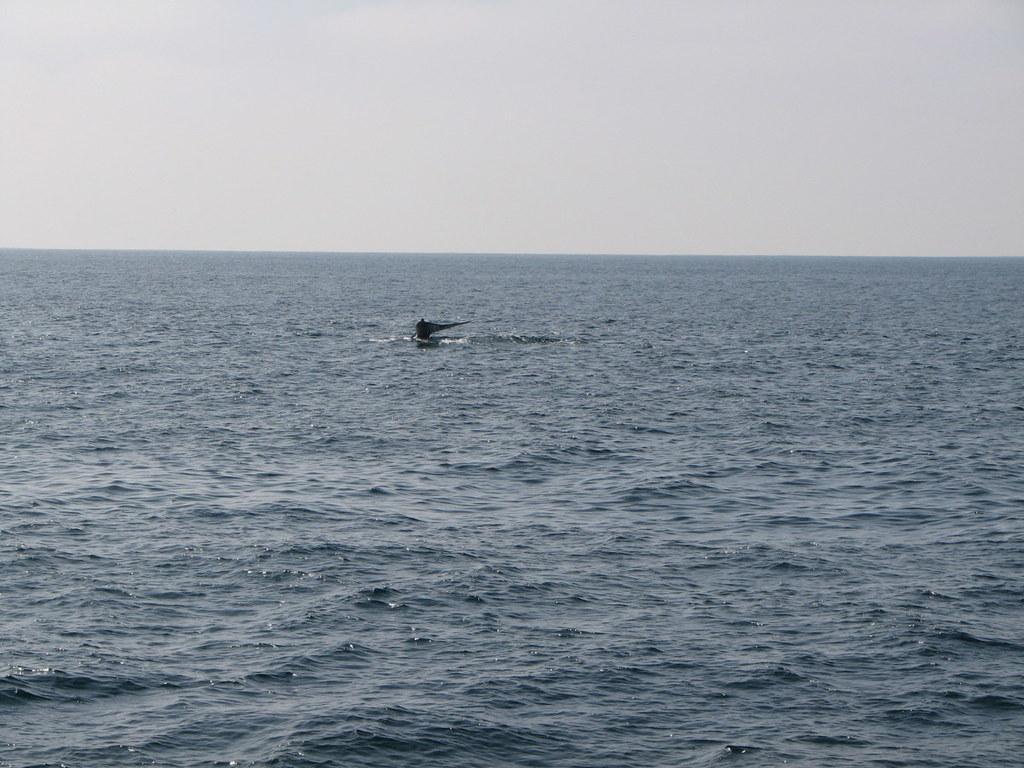In one or two sentences, can you explain what this image depicts? In this image we can see a black color object on the water and the sky in the background. 